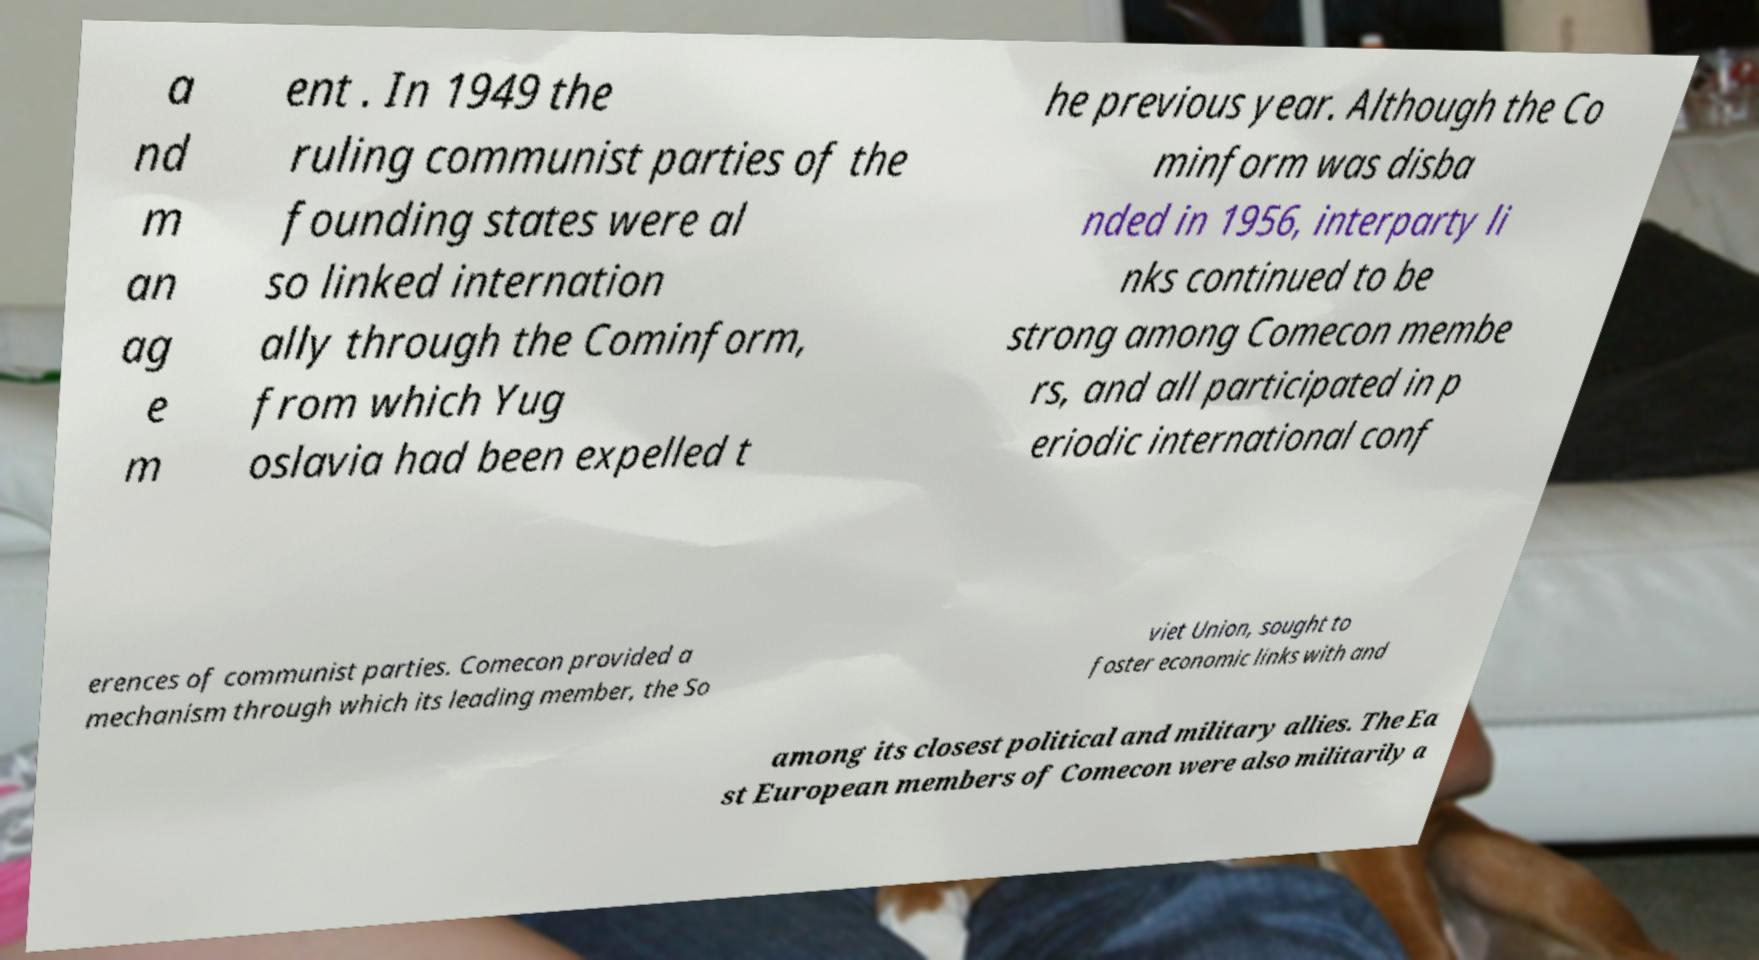Can you read and provide the text displayed in the image?This photo seems to have some interesting text. Can you extract and type it out for me? a nd m an ag e m ent . In 1949 the ruling communist parties of the founding states were al so linked internation ally through the Cominform, from which Yug oslavia had been expelled t he previous year. Although the Co minform was disba nded in 1956, interparty li nks continued to be strong among Comecon membe rs, and all participated in p eriodic international conf erences of communist parties. Comecon provided a mechanism through which its leading member, the So viet Union, sought to foster economic links with and among its closest political and military allies. The Ea st European members of Comecon were also militarily a 